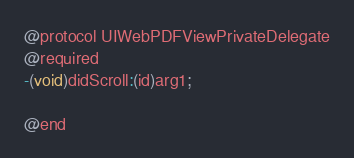Convert code to text. <code><loc_0><loc_0><loc_500><loc_500><_C_>

@protocol UIWebPDFViewPrivateDelegate
@required
-(void)didScroll:(id)arg1;

@end

</code> 